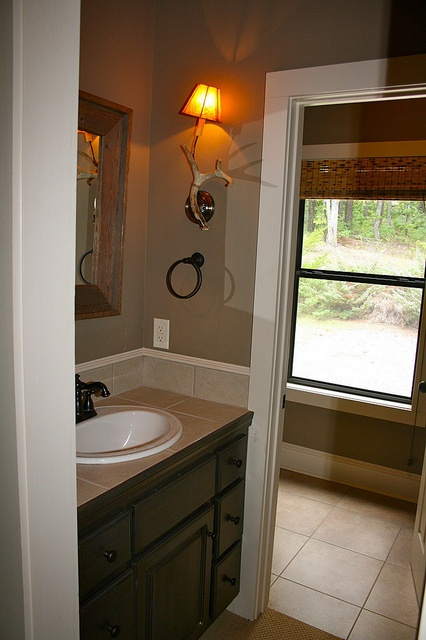Describe the objects in this image and their specific colors. I can see a sink in black, darkgray, and gray tones in this image. 